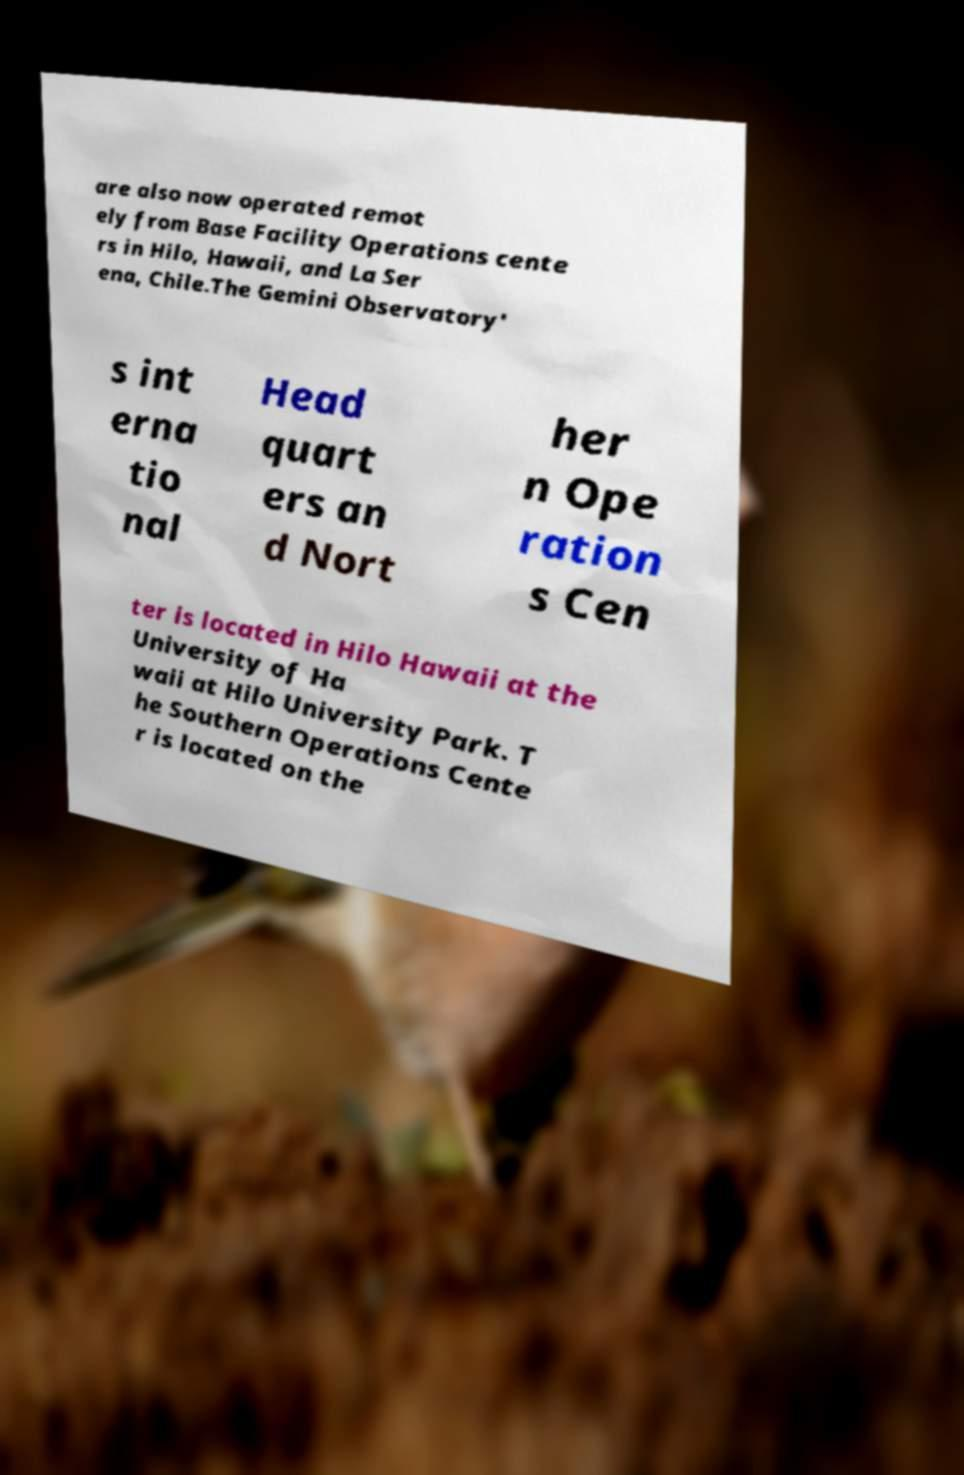For documentation purposes, I need the text within this image transcribed. Could you provide that? are also now operated remot ely from Base Facility Operations cente rs in Hilo, Hawaii, and La Ser ena, Chile.The Gemini Observatory' s int erna tio nal Head quart ers an d Nort her n Ope ration s Cen ter is located in Hilo Hawaii at the University of Ha waii at Hilo University Park. T he Southern Operations Cente r is located on the 